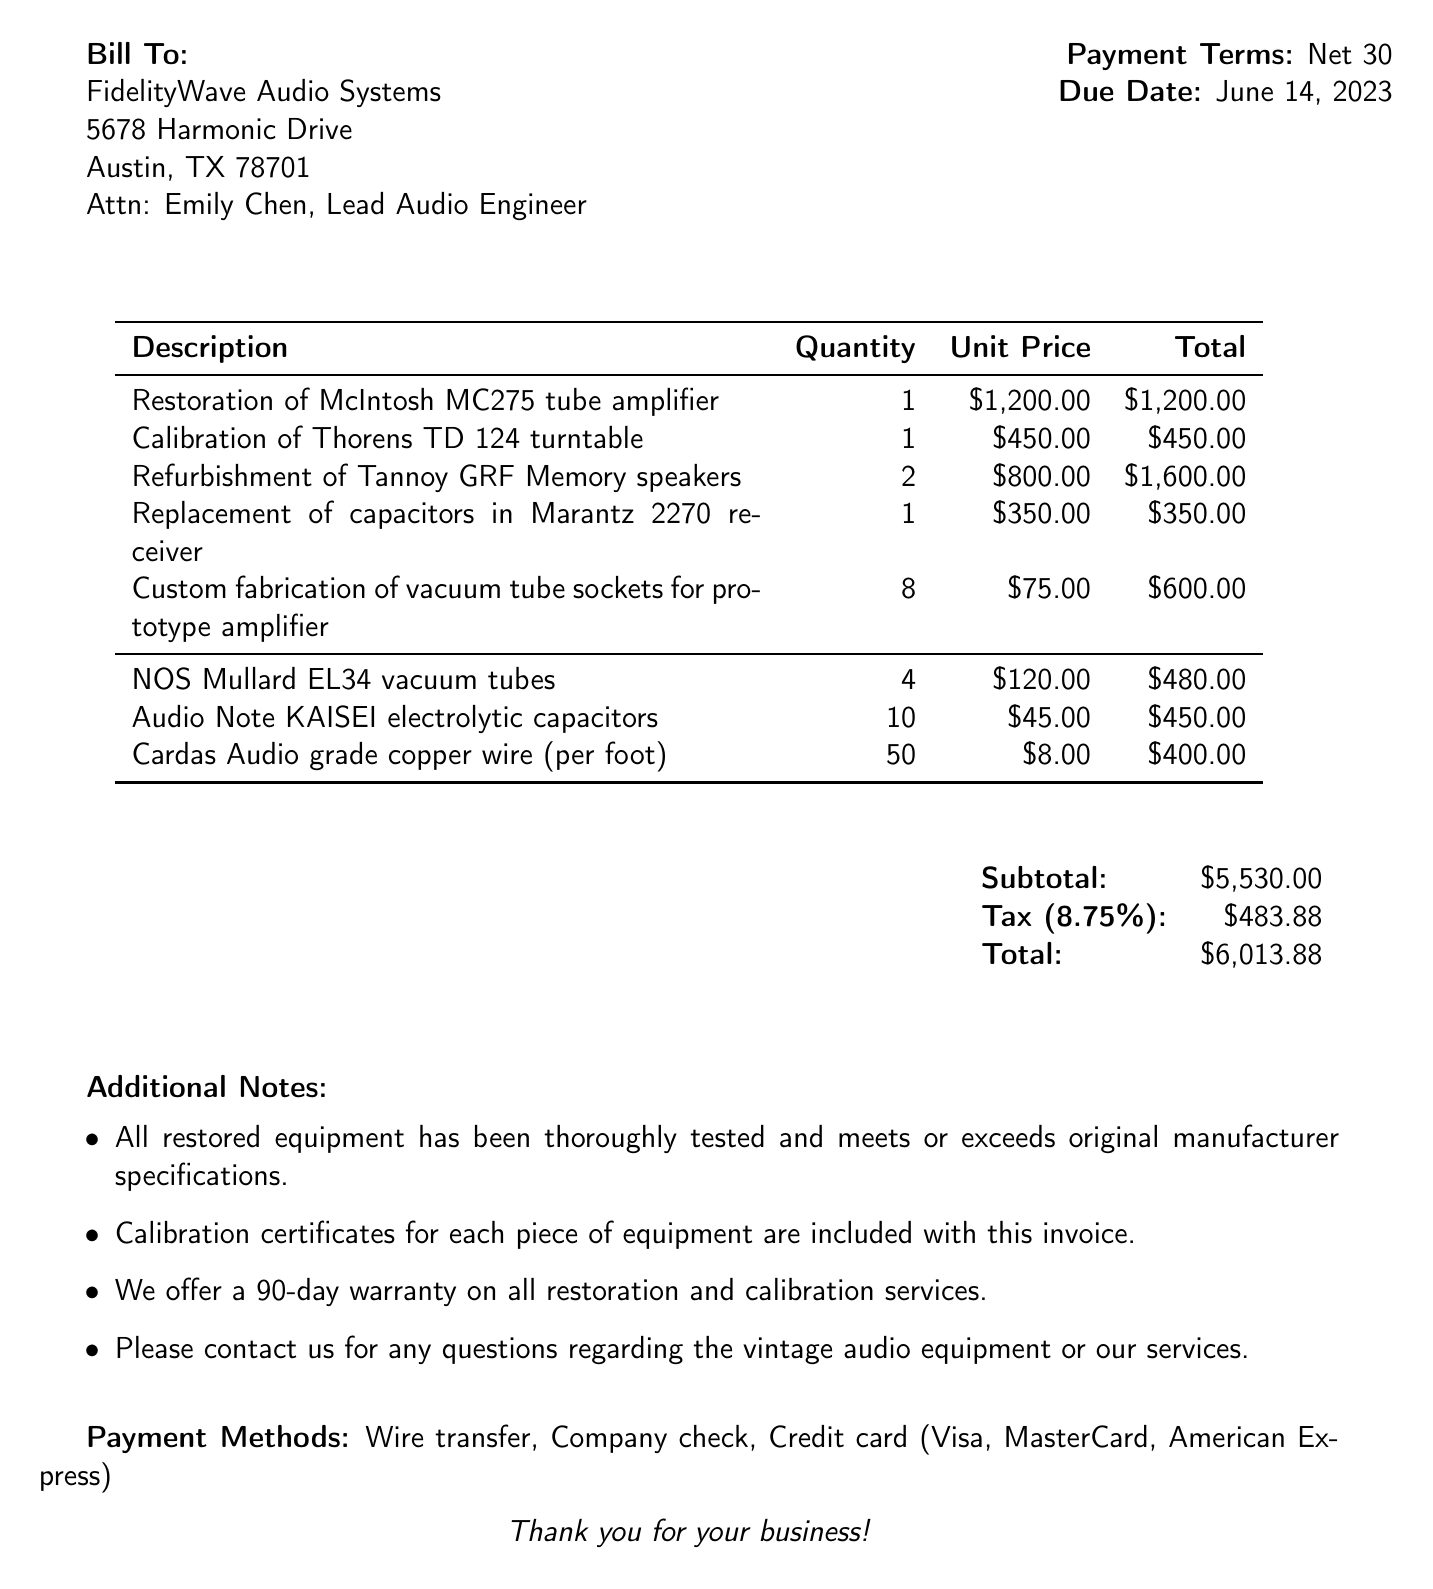what is the invoice number? The invoice number is listed under invoice details at the top of the document.
Answer: INV-2023-0542 who is the client contact person? The client contact person is mentioned in the client information section of the document.
Answer: Emily Chen, Lead Audio Engineer when is the due date? The due date is specified in the invoice details section of the document.
Answer: June 14, 2023 what is the subtotal amount? The subtotal amount is provided in the financial summary section towards the end of the document.
Answer: $5,530.00 how many NOS Mullard EL34 vacuum tubes are included? The quantity of NOS Mullard EL34 vacuum tubes is detailed in the materials section of the document.
Answer: 4 what percentage is the tax rate? The tax rate is indicated in the financial summary portion of the document.
Answer: 8.75% how many services are listed in the invoice? The number of services can be counted from the services section of the document.
Answer: 5 what is the payment term? The payment term is stated in the payment terms section of the document.
Answer: Net 30 are calibration certificates included with the invoice? The additional notes section mentions the inclusion of calibration certificates.
Answer: Yes 